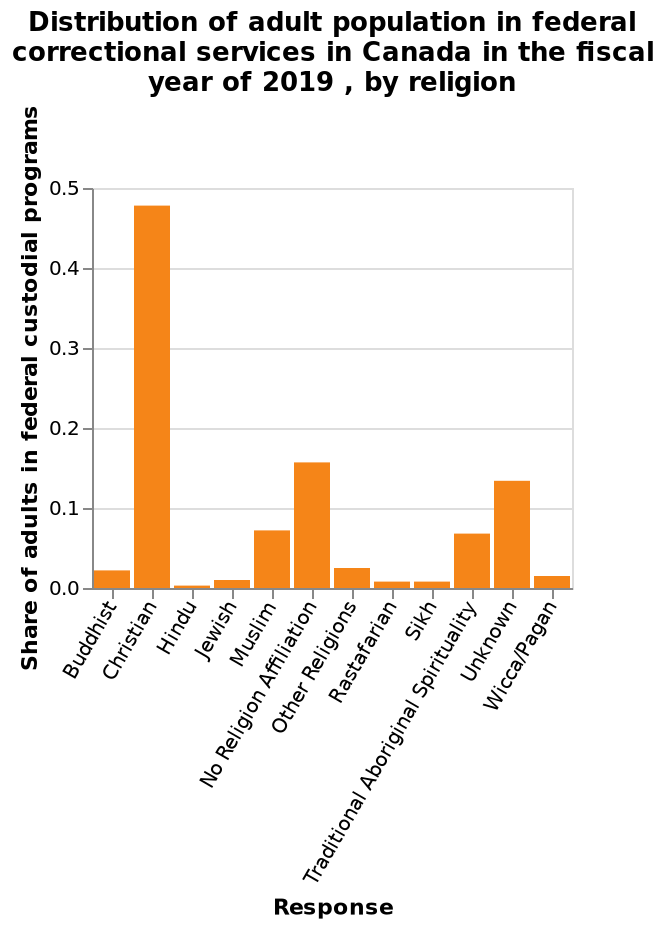<image>
What does the y-axis represent in the bar graph? The y-axis represents the share of adults in federal custodial programs, measured on a linear scale from 0.0 to 0.5. What does the x-axis represent in the bar graph? The x-axis represents different religions, ranging from Buddhist to Wicca/Pagan. Which religious group had the highest representation among prisoners in Canada in 2019? Among prisoners in Canada in 2019, Christians had the highest representation. Were Christians the majority or minority in the prison population in Canada in 2019? Christians were the majority in the prison population in Canada in 2019. 